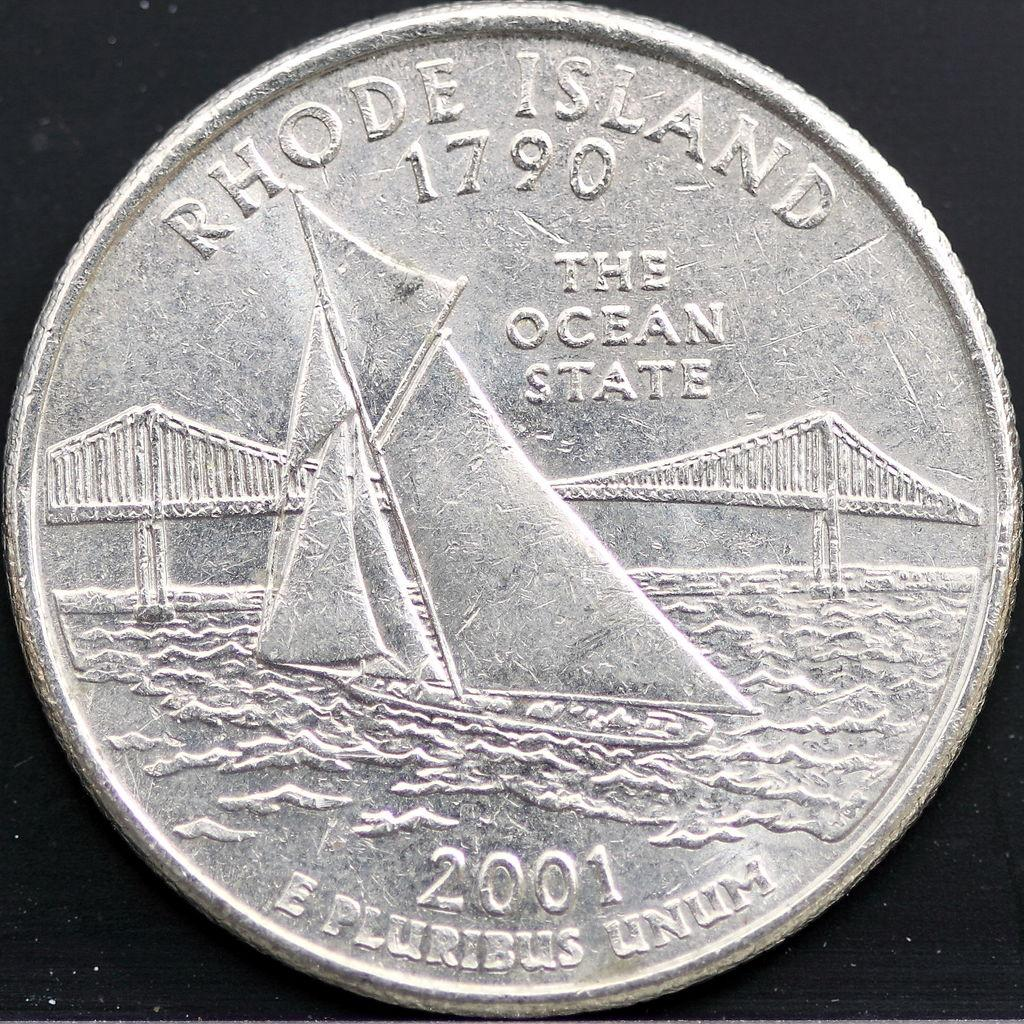<image>
Offer a succinct explanation of the picture presented. A state coin for Rhode Island features a sailboat in the water. 